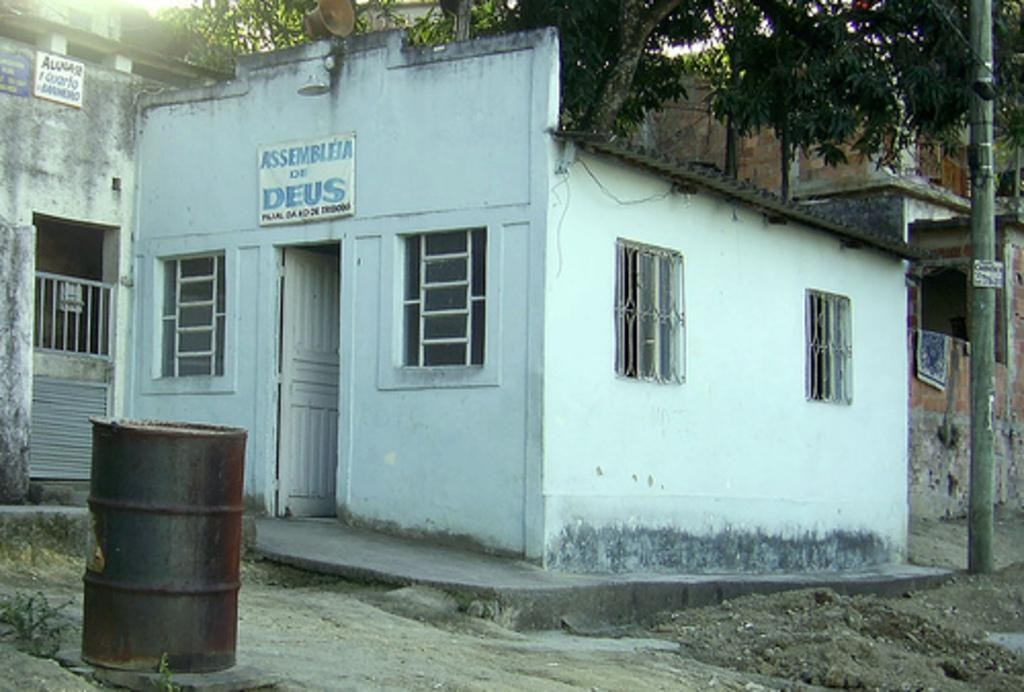<image>
Render a clear and concise summary of the photo. A small white building says Assembleia of Deus. 